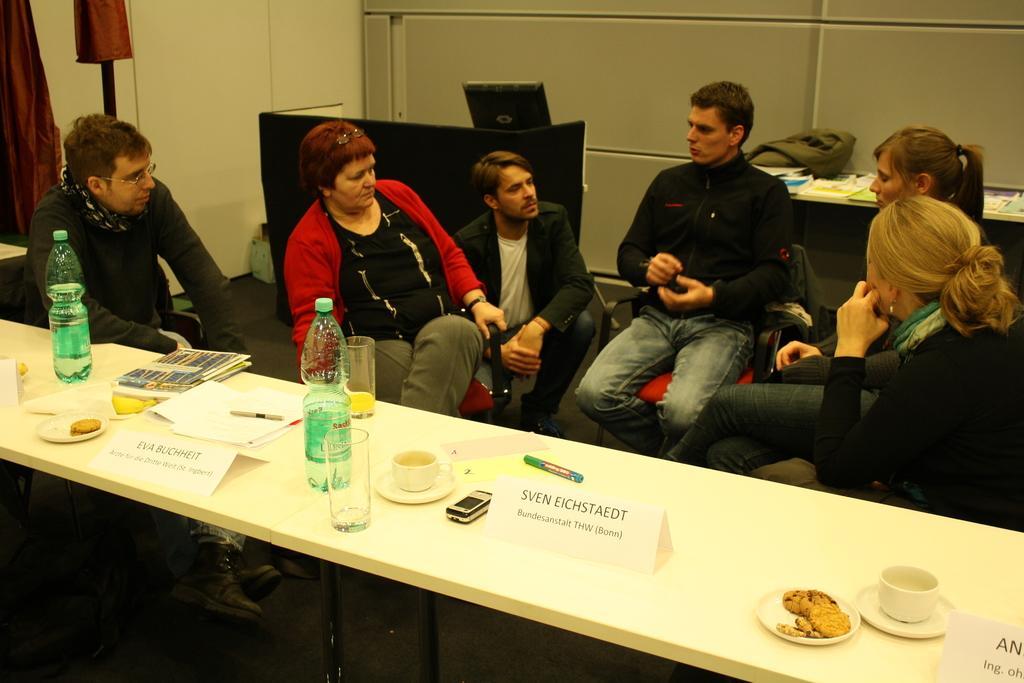Describe this image in one or two sentences. this picture shows a group of people seated on the chairs and we see water bottle, glasses ,tea cups on the table and we see a monitor on the back 